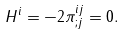Convert formula to latex. <formula><loc_0><loc_0><loc_500><loc_500>H ^ { i } = - 2 \pi ^ { i j } _ { ; j } = 0 .</formula> 